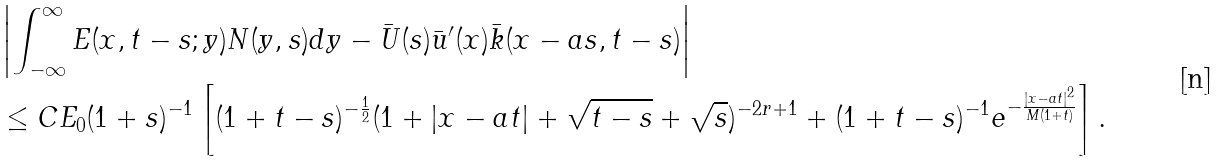<formula> <loc_0><loc_0><loc_500><loc_500>& \left | \int _ { - \infty } ^ { \infty } E ( x , t - s ; y ) N ( y , s ) d y - \bar { U } ( s ) \bar { u } ^ { \prime } ( x ) \bar { k } ( x - a s , t - s ) \right | \\ & \leq C E _ { 0 } ( 1 + s ) ^ { - 1 } \left [ ( 1 + t - s ) ^ { - \frac { 1 } { 2 } } ( 1 + | x - a t | + \sqrt { t - s } + \sqrt { s } ) ^ { - 2 r + 1 } + ( 1 + t - s ) ^ { - 1 } e ^ { - \frac { | x - a t | ^ { 2 } } { M ( 1 + t ) } } \right ] .</formula> 